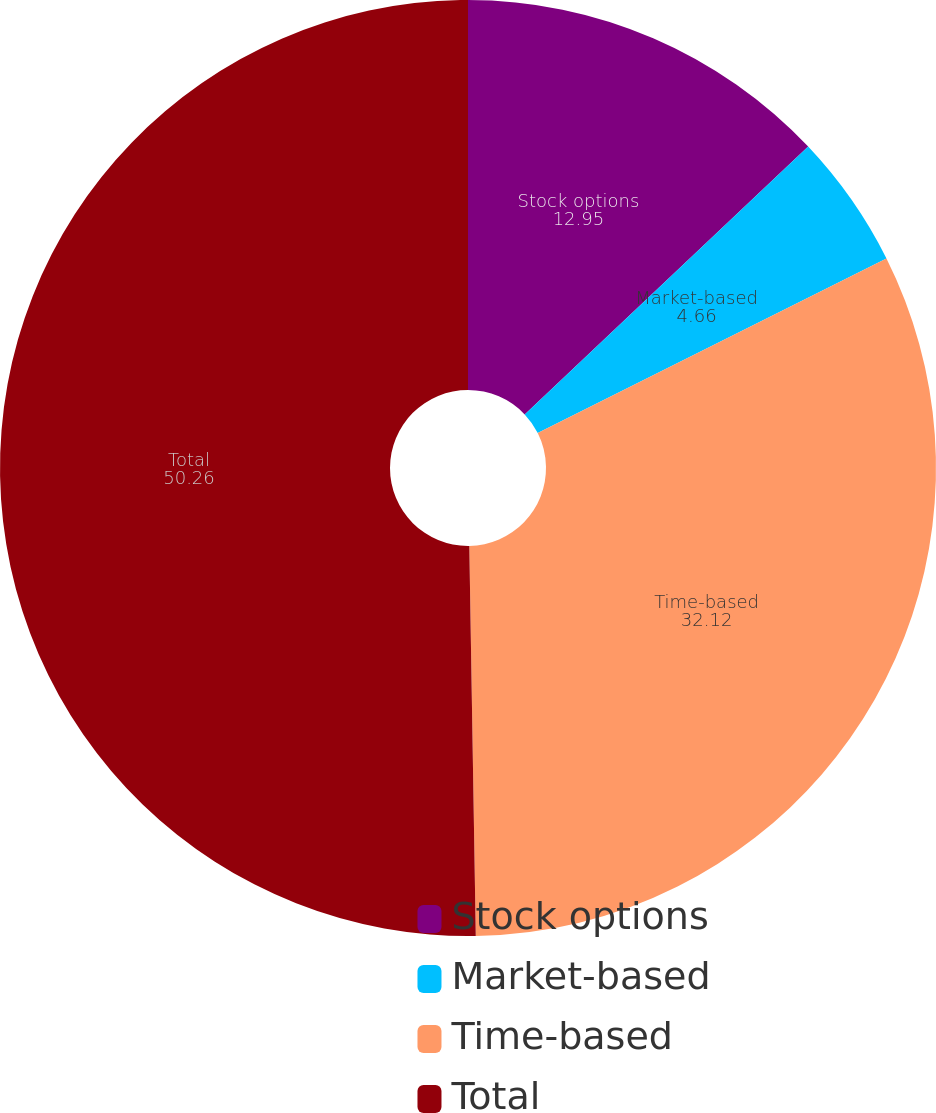<chart> <loc_0><loc_0><loc_500><loc_500><pie_chart><fcel>Stock options<fcel>Market-based<fcel>Time-based<fcel>Total<nl><fcel>12.95%<fcel>4.66%<fcel>32.12%<fcel>50.26%<nl></chart> 